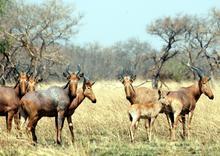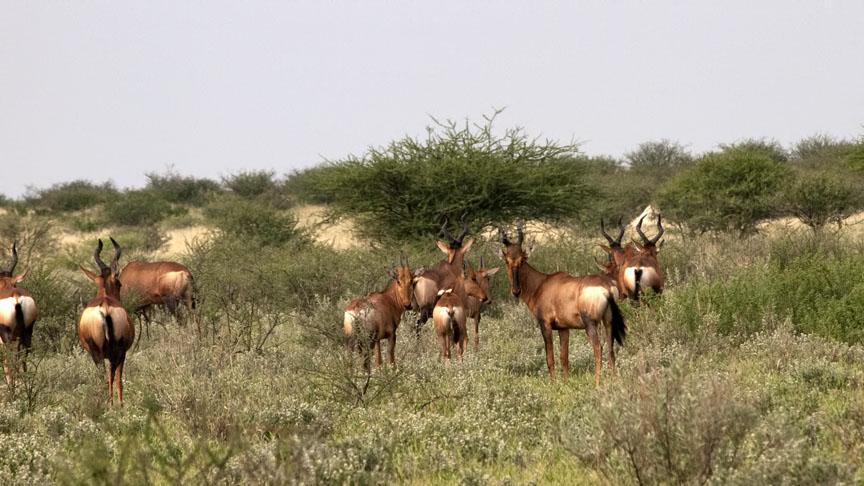The first image is the image on the left, the second image is the image on the right. Evaluate the accuracy of this statement regarding the images: "At least ten animals are standing in a grassy field.". Is it true? Answer yes or no. Yes. The first image is the image on the left, the second image is the image on the right. Evaluate the accuracy of this statement regarding the images: "The horned animals in one image are all standing with their rears showing.". Is it true? Answer yes or no. Yes. 